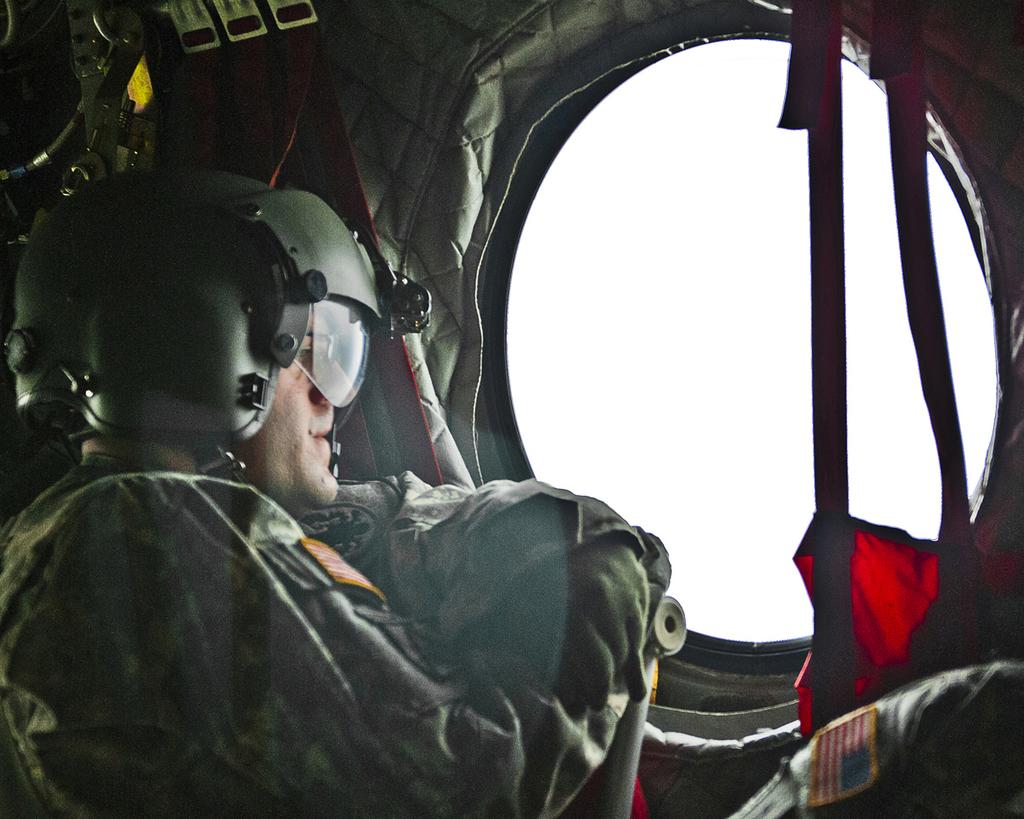What is the person in the image doing? The person is in an aircraft. What is the person wearing in the image? The person is wearing a helmet. What can be seen securing the person in the image? There are straps visible. What is visible through the window in the image? The sky is visible. What memory is the person trying to crush in the image? There is no indication in the image that the person is trying to crush a memory or any object. 